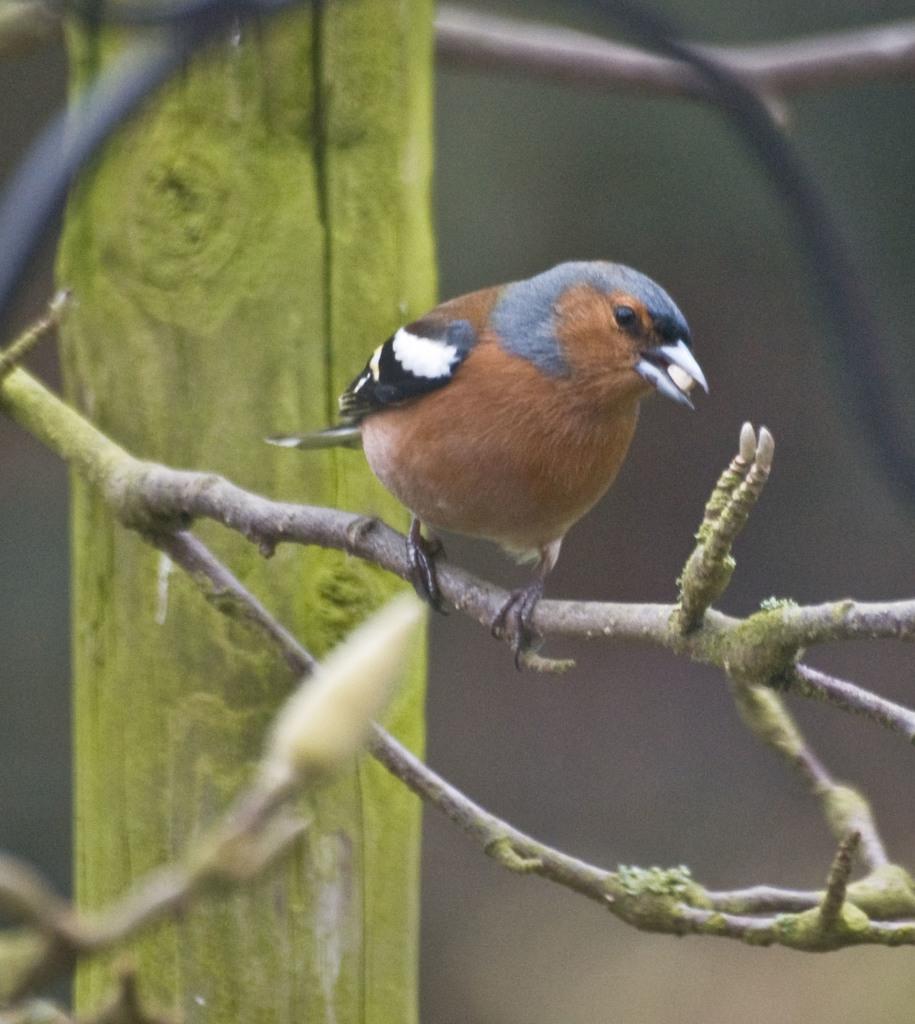In one or two sentences, can you explain what this image depicts? This image consists of a bird in brown color. It is sitting on a stem. In the background, there is a stick. 